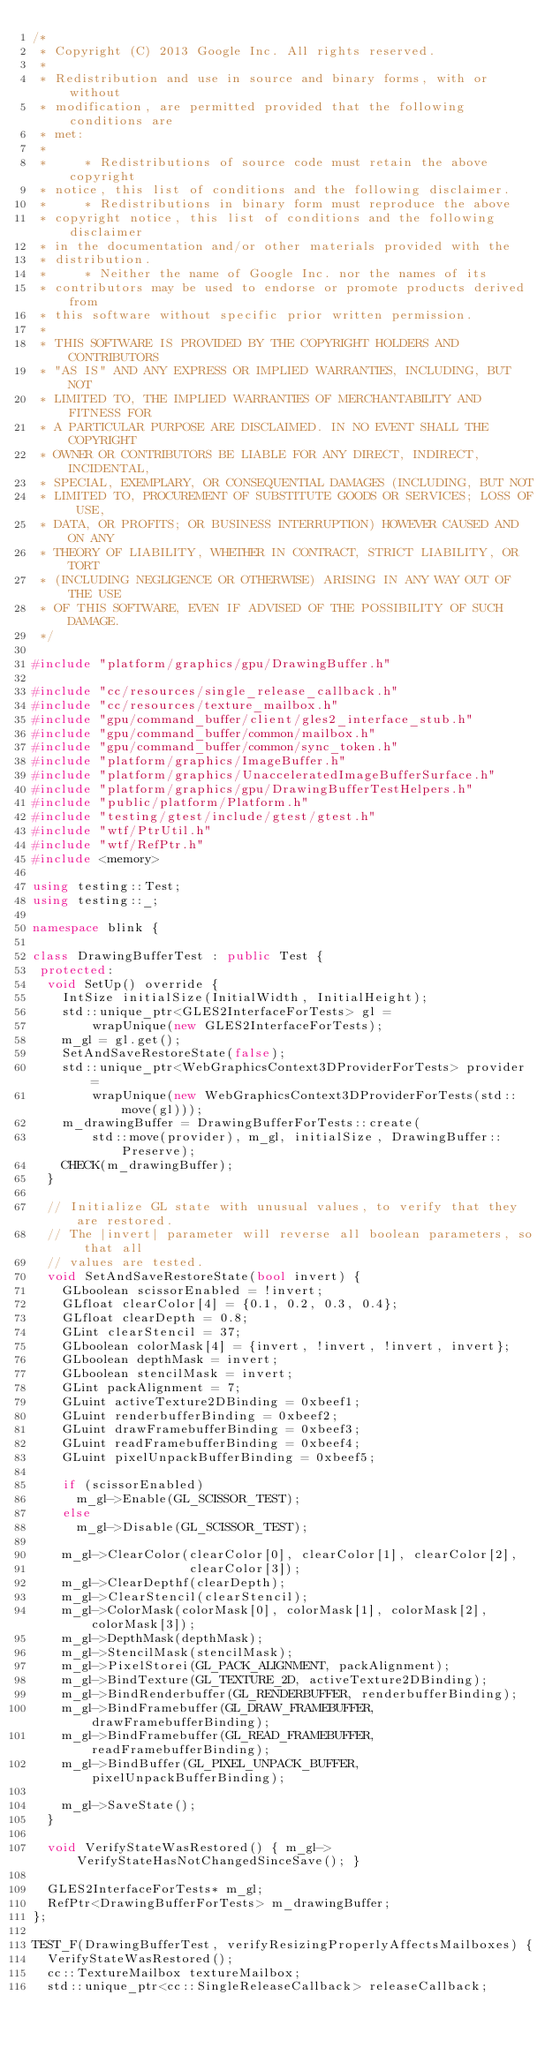<code> <loc_0><loc_0><loc_500><loc_500><_C++_>/*
 * Copyright (C) 2013 Google Inc. All rights reserved.
 *
 * Redistribution and use in source and binary forms, with or without
 * modification, are permitted provided that the following conditions are
 * met:
 *
 *     * Redistributions of source code must retain the above copyright
 * notice, this list of conditions and the following disclaimer.
 *     * Redistributions in binary form must reproduce the above
 * copyright notice, this list of conditions and the following disclaimer
 * in the documentation and/or other materials provided with the
 * distribution.
 *     * Neither the name of Google Inc. nor the names of its
 * contributors may be used to endorse or promote products derived from
 * this software without specific prior written permission.
 *
 * THIS SOFTWARE IS PROVIDED BY THE COPYRIGHT HOLDERS AND CONTRIBUTORS
 * "AS IS" AND ANY EXPRESS OR IMPLIED WARRANTIES, INCLUDING, BUT NOT
 * LIMITED TO, THE IMPLIED WARRANTIES OF MERCHANTABILITY AND FITNESS FOR
 * A PARTICULAR PURPOSE ARE DISCLAIMED. IN NO EVENT SHALL THE COPYRIGHT
 * OWNER OR CONTRIBUTORS BE LIABLE FOR ANY DIRECT, INDIRECT, INCIDENTAL,
 * SPECIAL, EXEMPLARY, OR CONSEQUENTIAL DAMAGES (INCLUDING, BUT NOT
 * LIMITED TO, PROCUREMENT OF SUBSTITUTE GOODS OR SERVICES; LOSS OF USE,
 * DATA, OR PROFITS; OR BUSINESS INTERRUPTION) HOWEVER CAUSED AND ON ANY
 * THEORY OF LIABILITY, WHETHER IN CONTRACT, STRICT LIABILITY, OR TORT
 * (INCLUDING NEGLIGENCE OR OTHERWISE) ARISING IN ANY WAY OUT OF THE USE
 * OF THIS SOFTWARE, EVEN IF ADVISED OF THE POSSIBILITY OF SUCH DAMAGE.
 */

#include "platform/graphics/gpu/DrawingBuffer.h"

#include "cc/resources/single_release_callback.h"
#include "cc/resources/texture_mailbox.h"
#include "gpu/command_buffer/client/gles2_interface_stub.h"
#include "gpu/command_buffer/common/mailbox.h"
#include "gpu/command_buffer/common/sync_token.h"
#include "platform/graphics/ImageBuffer.h"
#include "platform/graphics/UnacceleratedImageBufferSurface.h"
#include "platform/graphics/gpu/DrawingBufferTestHelpers.h"
#include "public/platform/Platform.h"
#include "testing/gtest/include/gtest/gtest.h"
#include "wtf/PtrUtil.h"
#include "wtf/RefPtr.h"
#include <memory>

using testing::Test;
using testing::_;

namespace blink {

class DrawingBufferTest : public Test {
 protected:
  void SetUp() override {
    IntSize initialSize(InitialWidth, InitialHeight);
    std::unique_ptr<GLES2InterfaceForTests> gl =
        wrapUnique(new GLES2InterfaceForTests);
    m_gl = gl.get();
    SetAndSaveRestoreState(false);
    std::unique_ptr<WebGraphicsContext3DProviderForTests> provider =
        wrapUnique(new WebGraphicsContext3DProviderForTests(std::move(gl)));
    m_drawingBuffer = DrawingBufferForTests::create(
        std::move(provider), m_gl, initialSize, DrawingBuffer::Preserve);
    CHECK(m_drawingBuffer);
  }

  // Initialize GL state with unusual values, to verify that they are restored.
  // The |invert| parameter will reverse all boolean parameters, so that all
  // values are tested.
  void SetAndSaveRestoreState(bool invert) {
    GLboolean scissorEnabled = !invert;
    GLfloat clearColor[4] = {0.1, 0.2, 0.3, 0.4};
    GLfloat clearDepth = 0.8;
    GLint clearStencil = 37;
    GLboolean colorMask[4] = {invert, !invert, !invert, invert};
    GLboolean depthMask = invert;
    GLboolean stencilMask = invert;
    GLint packAlignment = 7;
    GLuint activeTexture2DBinding = 0xbeef1;
    GLuint renderbufferBinding = 0xbeef2;
    GLuint drawFramebufferBinding = 0xbeef3;
    GLuint readFramebufferBinding = 0xbeef4;
    GLuint pixelUnpackBufferBinding = 0xbeef5;

    if (scissorEnabled)
      m_gl->Enable(GL_SCISSOR_TEST);
    else
      m_gl->Disable(GL_SCISSOR_TEST);

    m_gl->ClearColor(clearColor[0], clearColor[1], clearColor[2],
                     clearColor[3]);
    m_gl->ClearDepthf(clearDepth);
    m_gl->ClearStencil(clearStencil);
    m_gl->ColorMask(colorMask[0], colorMask[1], colorMask[2], colorMask[3]);
    m_gl->DepthMask(depthMask);
    m_gl->StencilMask(stencilMask);
    m_gl->PixelStorei(GL_PACK_ALIGNMENT, packAlignment);
    m_gl->BindTexture(GL_TEXTURE_2D, activeTexture2DBinding);
    m_gl->BindRenderbuffer(GL_RENDERBUFFER, renderbufferBinding);
    m_gl->BindFramebuffer(GL_DRAW_FRAMEBUFFER, drawFramebufferBinding);
    m_gl->BindFramebuffer(GL_READ_FRAMEBUFFER, readFramebufferBinding);
    m_gl->BindBuffer(GL_PIXEL_UNPACK_BUFFER, pixelUnpackBufferBinding);

    m_gl->SaveState();
  }

  void VerifyStateWasRestored() { m_gl->VerifyStateHasNotChangedSinceSave(); }

  GLES2InterfaceForTests* m_gl;
  RefPtr<DrawingBufferForTests> m_drawingBuffer;
};

TEST_F(DrawingBufferTest, verifyResizingProperlyAffectsMailboxes) {
  VerifyStateWasRestored();
  cc::TextureMailbox textureMailbox;
  std::unique_ptr<cc::SingleReleaseCallback> releaseCallback;
</code> 